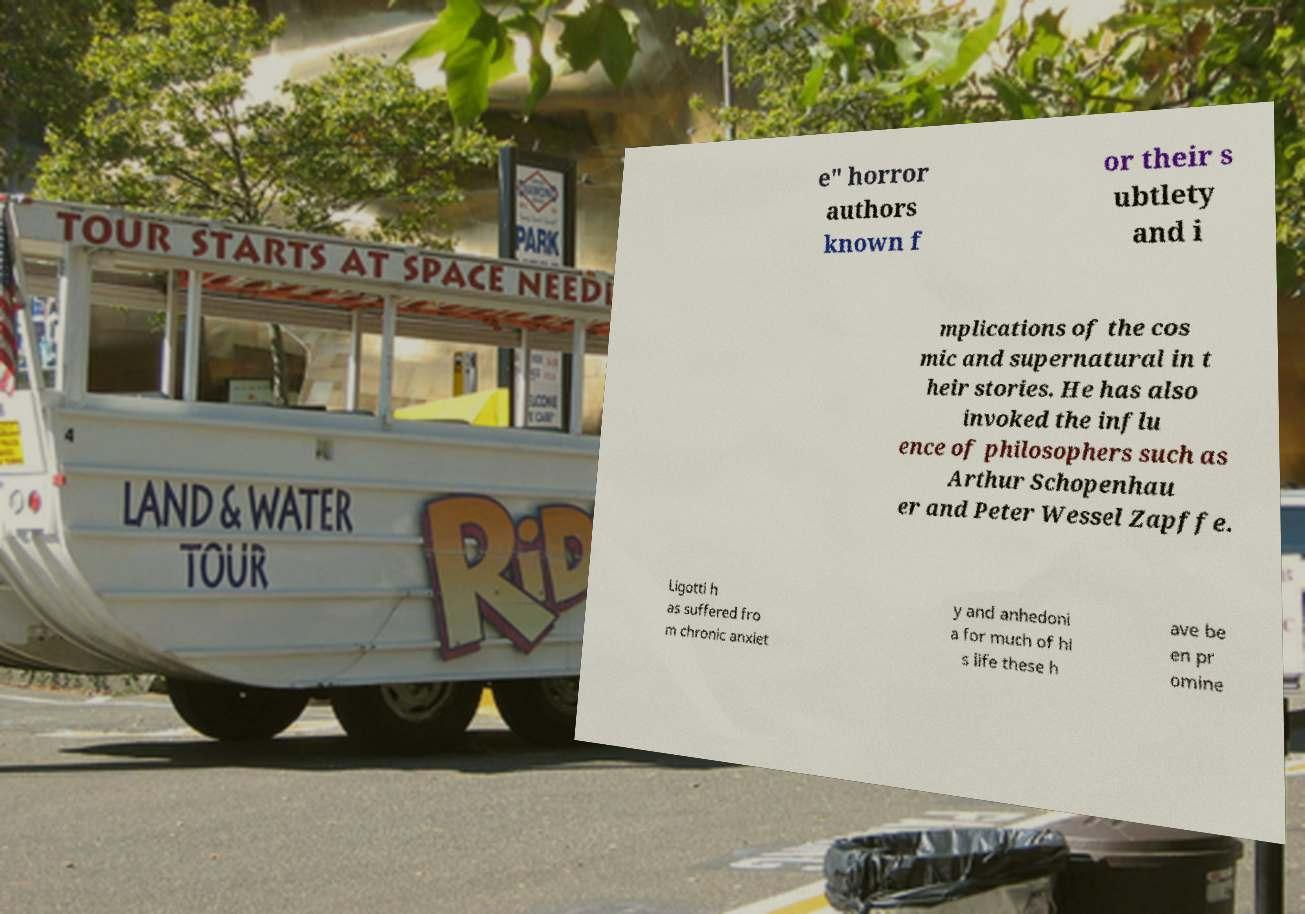Could you assist in decoding the text presented in this image and type it out clearly? e" horror authors known f or their s ubtlety and i mplications of the cos mic and supernatural in t heir stories. He has also invoked the influ ence of philosophers such as Arthur Schopenhau er and Peter Wessel Zapffe. Ligotti h as suffered fro m chronic anxiet y and anhedoni a for much of hi s life these h ave be en pr omine 